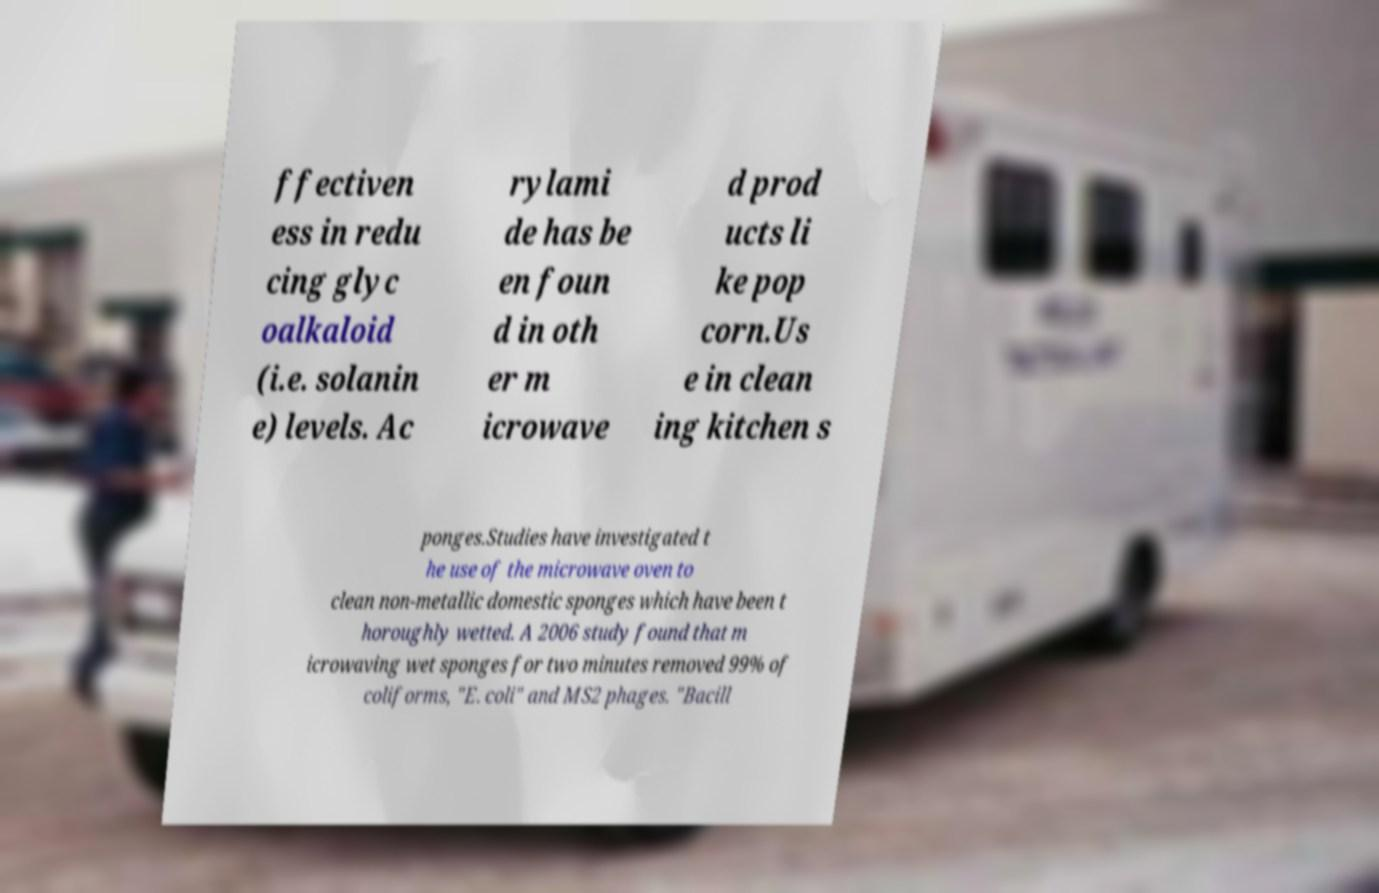Please identify and transcribe the text found in this image. ffectiven ess in redu cing glyc oalkaloid (i.e. solanin e) levels. Ac rylami de has be en foun d in oth er m icrowave d prod ucts li ke pop corn.Us e in clean ing kitchen s ponges.Studies have investigated t he use of the microwave oven to clean non-metallic domestic sponges which have been t horoughly wetted. A 2006 study found that m icrowaving wet sponges for two minutes removed 99% of coliforms, "E. coli" and MS2 phages. "Bacill 